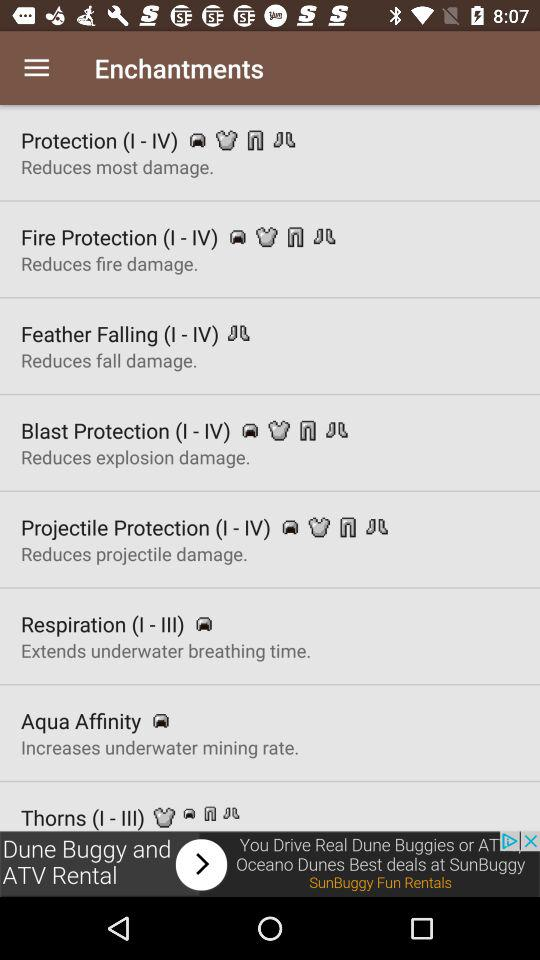What are the different enhancements available? The different enhancements available are: "Protection (I-IV)", "Fire Protection (I-IV)", "Feather Falling (I-IV) ","Blast Protection (I-IV) ", "Projectile Protection (I-IV)","Respiration (I-III) ","Aqua Affinity ", and "Thorns (I-III)". 